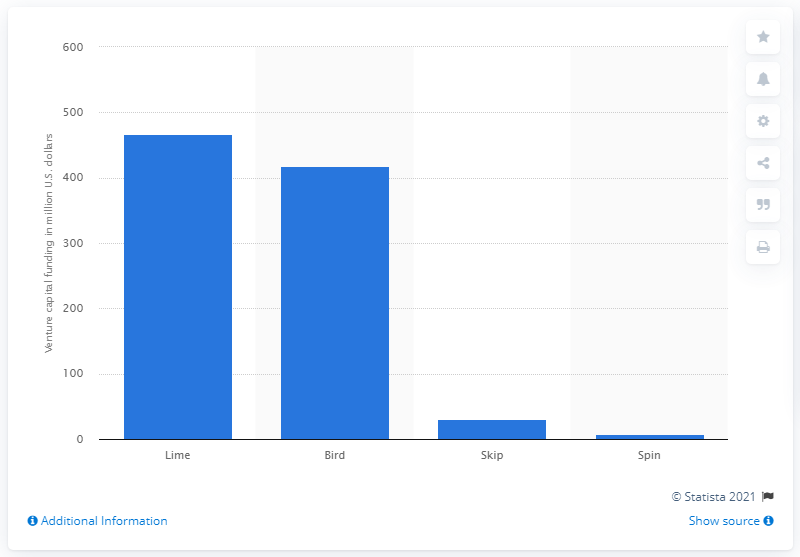Mention a couple of crucial points in this snapshot. According to information available as of 2018, Lime, a scooter startup, raised around 467 million U.S. dollars in venture capital funding. 